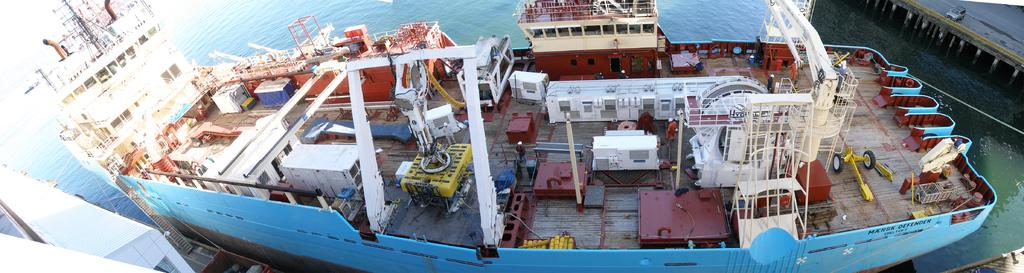What is the main subject in the water body in the image? There is a ship in the water body in the image. What feature can be seen on the ship? There is a ladder on the ship. What else is present on the ship? There are objects on the ship. What can be seen in the background of the image? There is a bridge visible in the image. What is on the bridge? There is a car on the bridge. What type of bait is being used by the fish in the image? There are no fish or bait present in the image; it features a ship in the water body and a bridge with a car. How does the behavior of the ship affect the car on the bridge? The ship's behavior does not affect the car on the bridge, as they are separate subjects in the image. 